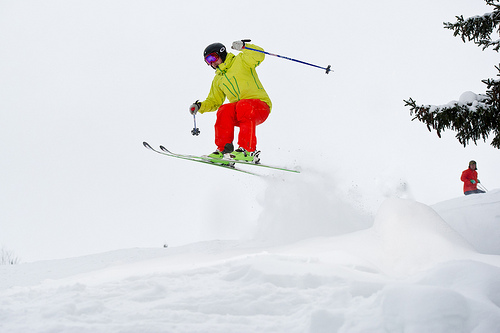Please provide the bounding box coordinate of the region this sentence describes: black helmet on head. The black helmet, securely positioned on the skier's head, is framed within the bounding box [0.41, 0.24, 0.46, 0.28]. 